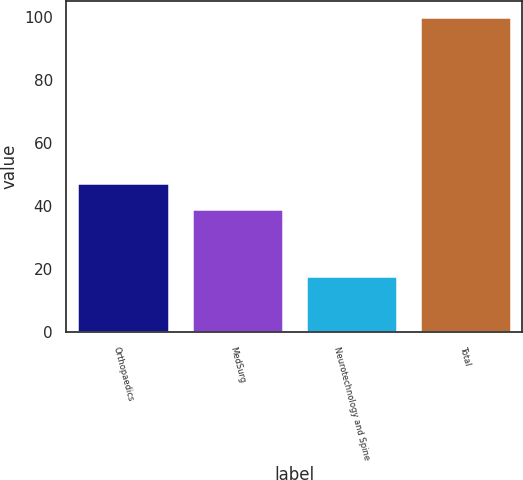<chart> <loc_0><loc_0><loc_500><loc_500><bar_chart><fcel>Orthopaedics<fcel>MedSurg<fcel>Neurotechnology and Spine<fcel>Total<nl><fcel>47.2<fcel>39<fcel>18<fcel>100<nl></chart> 